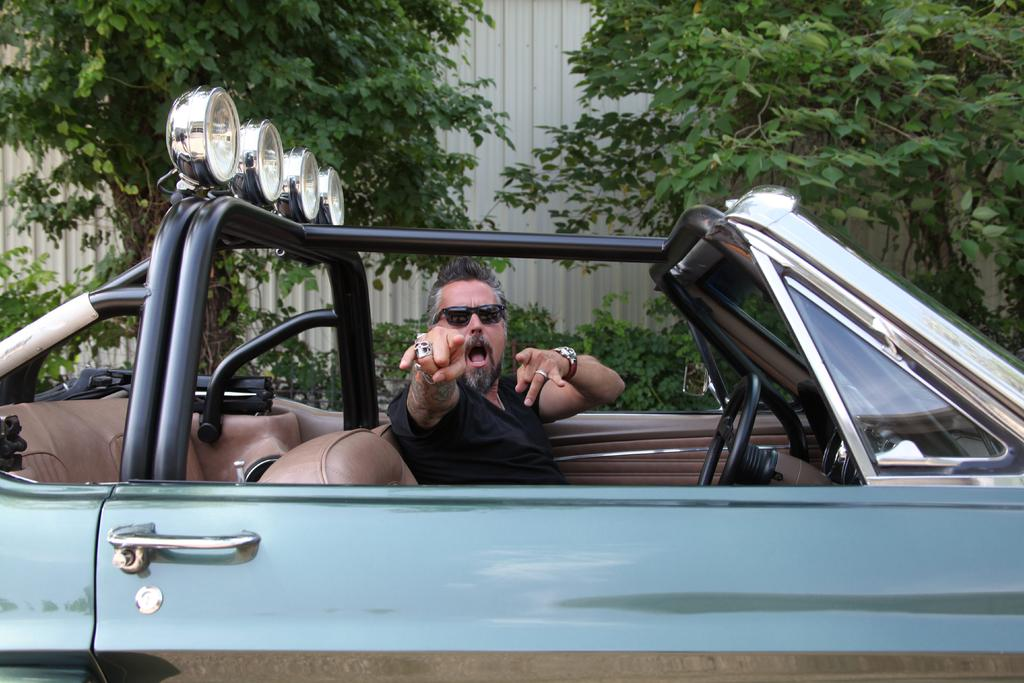Who is present in the image? There is a person in the image. What is the person wearing? The person is wearing a black dress. Where is the person located in the image? The person is sitting in a car. What can be seen in the background of the image? There are trees beside the car. What type of scarecrow is standing next to the car in the image? There is no scarecrow present in the image; it features a person sitting in a car with trees in the background. What type of skirt is the person wearing in the image? The person is wearing a black dress, not a skirt, in the image. 